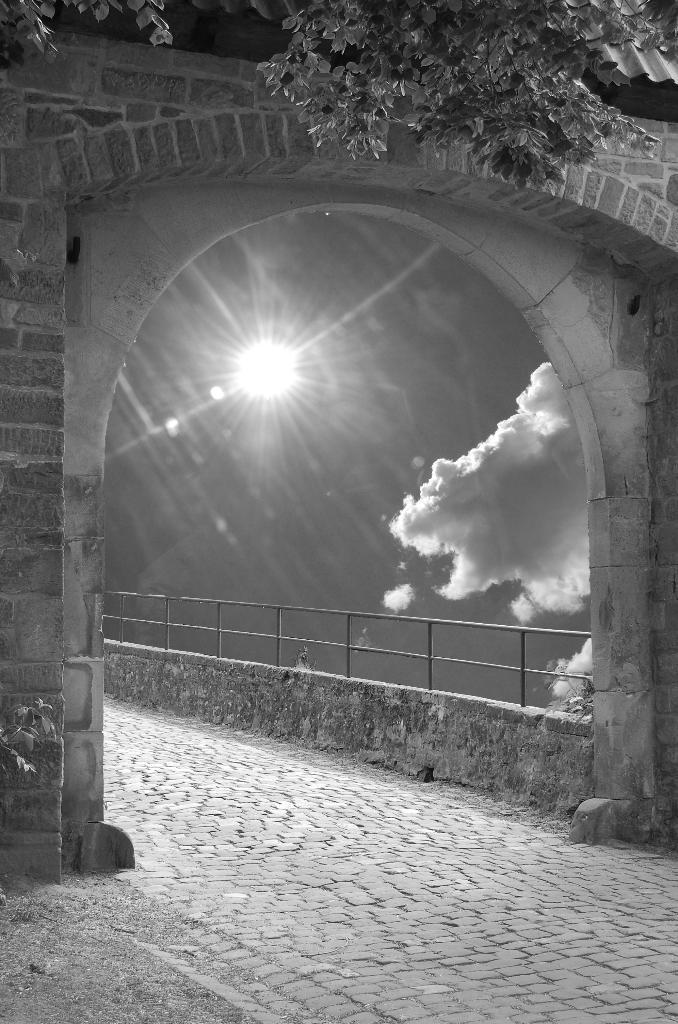What is the color scheme of the image? The image is black and white. What type of structure can be seen in the image? There is an arch in the image. What can be used for walking or strolling in the image? There is a walking path in the image. What feature is present to provide safety or support in the image? Railings are present in the image. What is visible in the background of the image? The sky is visible in the image. What type of weather can be inferred from the image? Clouds are present in the sky, suggesting that it might be a partly cloudy day. Can you see any fish swimming in the image? There are no fish present in the image. Why is the person in the image crying? There is no person present in the image, so it is not possible to determine if anyone is crying. 